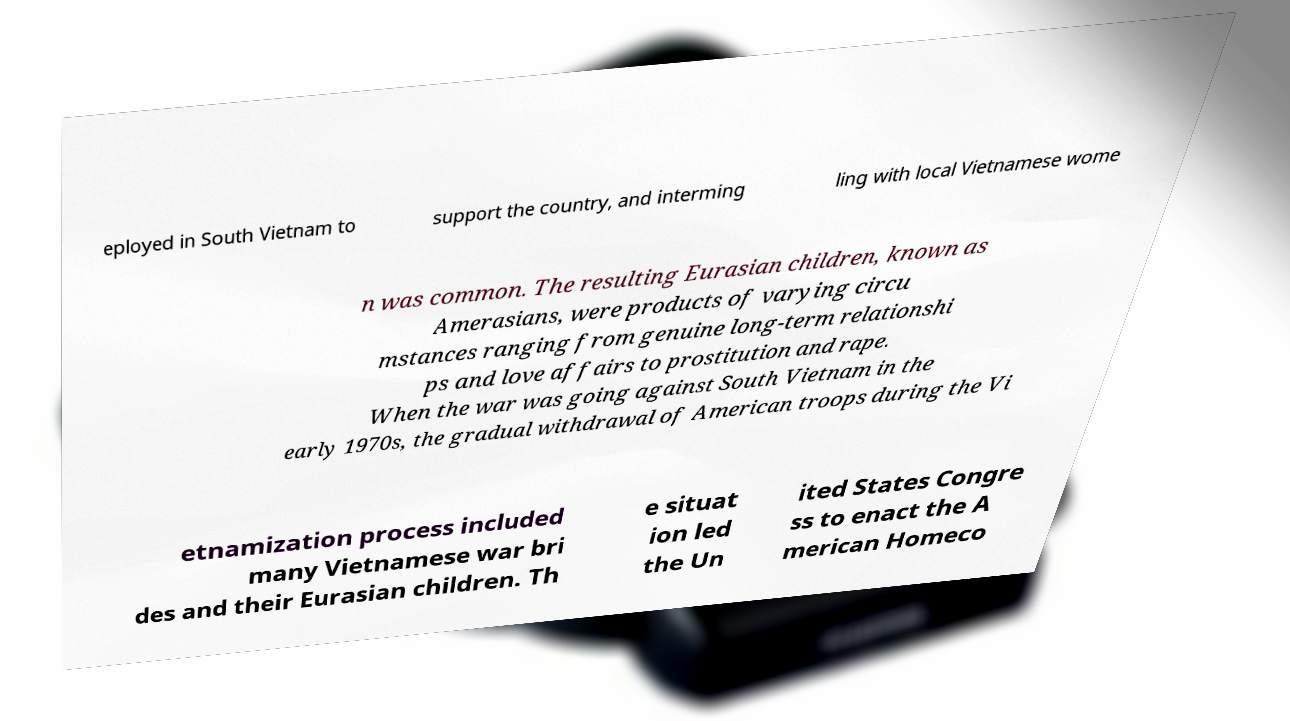Please read and relay the text visible in this image. What does it say? eployed in South Vietnam to support the country, and interming ling with local Vietnamese wome n was common. The resulting Eurasian children, known as Amerasians, were products of varying circu mstances ranging from genuine long-term relationshi ps and love affairs to prostitution and rape. When the war was going against South Vietnam in the early 1970s, the gradual withdrawal of American troops during the Vi etnamization process included many Vietnamese war bri des and their Eurasian children. Th e situat ion led the Un ited States Congre ss to enact the A merican Homeco 